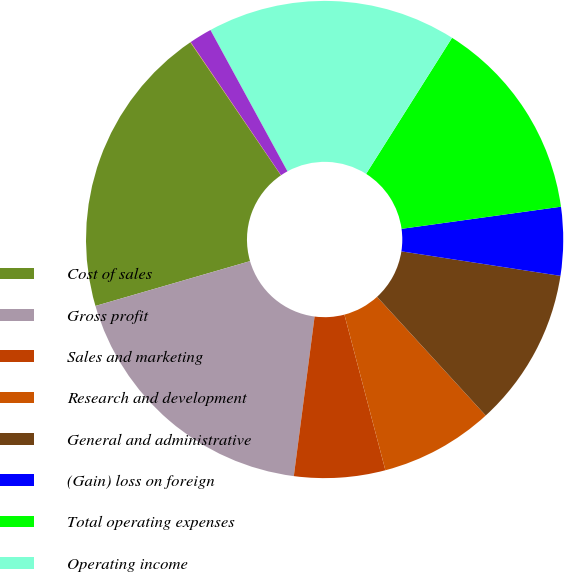Convert chart to OTSL. <chart><loc_0><loc_0><loc_500><loc_500><pie_chart><fcel>Cost of sales<fcel>Gross profit<fcel>Sales and marketing<fcel>Research and development<fcel>General and administrative<fcel>(Gain) loss on foreign<fcel>Total operating expenses<fcel>Operating income<fcel>Interest expense net<fcel>Other income (expense) net<nl><fcel>19.98%<fcel>18.45%<fcel>6.16%<fcel>7.7%<fcel>10.77%<fcel>4.63%<fcel>13.84%<fcel>16.91%<fcel>1.55%<fcel>0.02%<nl></chart> 